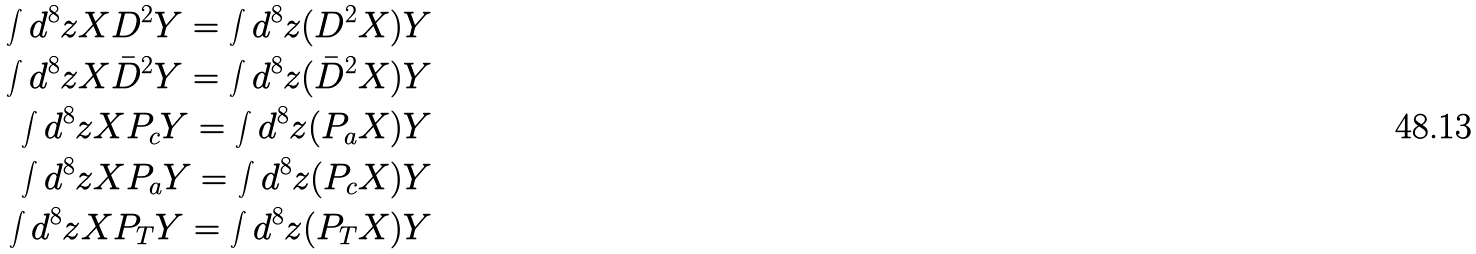Convert formula to latex. <formula><loc_0><loc_0><loc_500><loc_500>\int d ^ { 8 } z X D ^ { 2 } Y = \int d ^ { 8 } z ( D ^ { 2 } X ) Y \\ \int d ^ { 8 } z X \bar { D } ^ { 2 } Y = \int d ^ { 8 } z ( \bar { D } ^ { 2 } X ) Y \\ \int d ^ { 8 } z X P _ { c } Y = \int d ^ { 8 } z ( P _ { a } X ) Y \\ \int d ^ { 8 } z X P _ { a } Y = \int d ^ { 8 } z ( P _ { c } X ) Y \\ \int d ^ { 8 } z X P _ { T } Y = \int d ^ { 8 } z ( P _ { T } X ) Y</formula> 